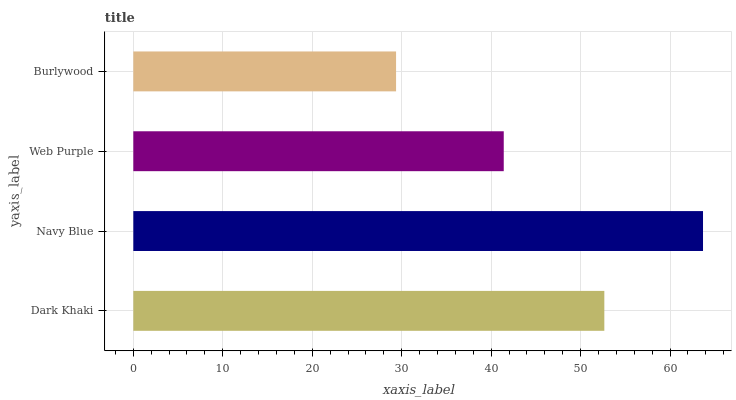Is Burlywood the minimum?
Answer yes or no. Yes. Is Navy Blue the maximum?
Answer yes or no. Yes. Is Web Purple the minimum?
Answer yes or no. No. Is Web Purple the maximum?
Answer yes or no. No. Is Navy Blue greater than Web Purple?
Answer yes or no. Yes. Is Web Purple less than Navy Blue?
Answer yes or no. Yes. Is Web Purple greater than Navy Blue?
Answer yes or no. No. Is Navy Blue less than Web Purple?
Answer yes or no. No. Is Dark Khaki the high median?
Answer yes or no. Yes. Is Web Purple the low median?
Answer yes or no. Yes. Is Navy Blue the high median?
Answer yes or no. No. Is Dark Khaki the low median?
Answer yes or no. No. 